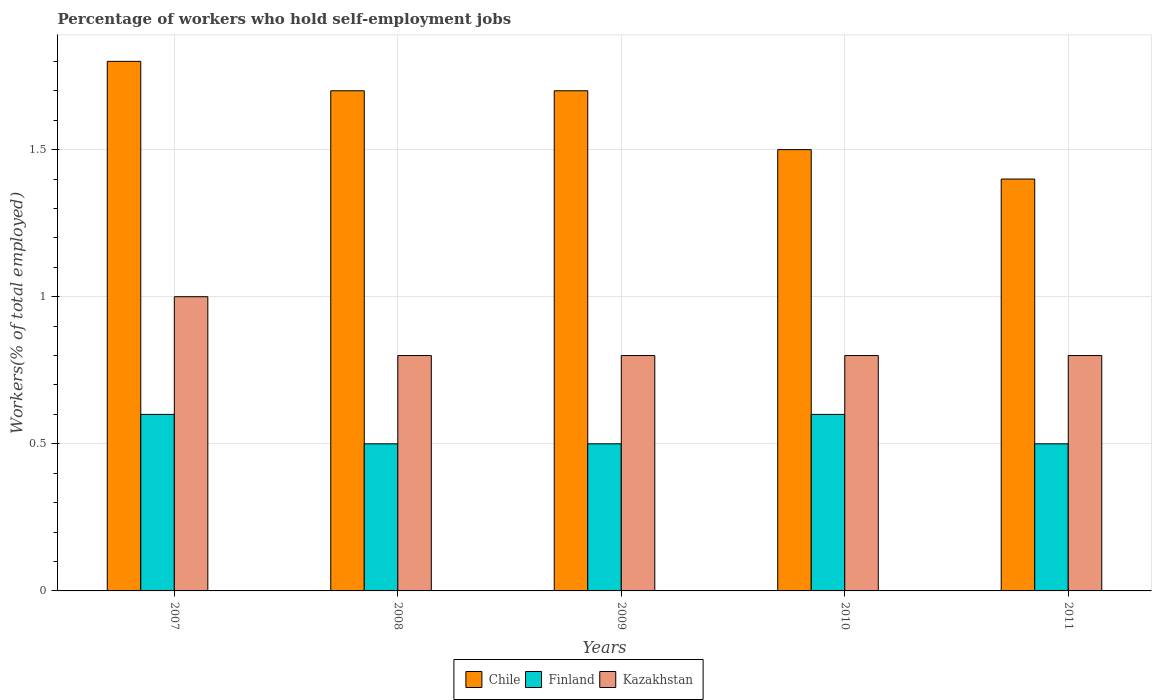How many different coloured bars are there?
Provide a short and direct response. 3. Are the number of bars per tick equal to the number of legend labels?
Your answer should be very brief. Yes. Are the number of bars on each tick of the X-axis equal?
Make the answer very short. Yes. In how many cases, is the number of bars for a given year not equal to the number of legend labels?
Offer a terse response. 0. What is the percentage of self-employed workers in Chile in 2011?
Ensure brevity in your answer.  1.4. Across all years, what is the maximum percentage of self-employed workers in Chile?
Provide a short and direct response. 1.8. Across all years, what is the minimum percentage of self-employed workers in Kazakhstan?
Offer a terse response. 0.8. In which year was the percentage of self-employed workers in Chile maximum?
Give a very brief answer. 2007. What is the total percentage of self-employed workers in Chile in the graph?
Keep it short and to the point. 8.1. What is the difference between the percentage of self-employed workers in Finland in 2007 and that in 2009?
Provide a short and direct response. 0.1. What is the difference between the percentage of self-employed workers in Finland in 2008 and the percentage of self-employed workers in Chile in 2009?
Offer a very short reply. -1.2. What is the average percentage of self-employed workers in Chile per year?
Give a very brief answer. 1.62. In the year 2007, what is the difference between the percentage of self-employed workers in Finland and percentage of self-employed workers in Chile?
Offer a very short reply. -1.2. What is the ratio of the percentage of self-employed workers in Chile in 2010 to that in 2011?
Keep it short and to the point. 1.07. Is the difference between the percentage of self-employed workers in Finland in 2008 and 2011 greater than the difference between the percentage of self-employed workers in Chile in 2008 and 2011?
Provide a short and direct response. No. What is the difference between the highest and the second highest percentage of self-employed workers in Kazakhstan?
Your answer should be compact. 0.2. What is the difference between the highest and the lowest percentage of self-employed workers in Chile?
Ensure brevity in your answer.  0.4. In how many years, is the percentage of self-employed workers in Chile greater than the average percentage of self-employed workers in Chile taken over all years?
Your answer should be very brief. 3. Are all the bars in the graph horizontal?
Make the answer very short. No. How many years are there in the graph?
Make the answer very short. 5. Where does the legend appear in the graph?
Keep it short and to the point. Bottom center. How many legend labels are there?
Make the answer very short. 3. How are the legend labels stacked?
Ensure brevity in your answer.  Horizontal. What is the title of the graph?
Your response must be concise. Percentage of workers who hold self-employment jobs. What is the label or title of the Y-axis?
Your response must be concise. Workers(% of total employed). What is the Workers(% of total employed) in Chile in 2007?
Provide a short and direct response. 1.8. What is the Workers(% of total employed) in Finland in 2007?
Your answer should be very brief. 0.6. What is the Workers(% of total employed) in Kazakhstan in 2007?
Your answer should be compact. 1. What is the Workers(% of total employed) in Chile in 2008?
Make the answer very short. 1.7. What is the Workers(% of total employed) of Kazakhstan in 2008?
Ensure brevity in your answer.  0.8. What is the Workers(% of total employed) of Chile in 2009?
Your answer should be very brief. 1.7. What is the Workers(% of total employed) of Finland in 2009?
Your answer should be very brief. 0.5. What is the Workers(% of total employed) in Kazakhstan in 2009?
Offer a terse response. 0.8. What is the Workers(% of total employed) in Chile in 2010?
Keep it short and to the point. 1.5. What is the Workers(% of total employed) in Finland in 2010?
Your answer should be very brief. 0.6. What is the Workers(% of total employed) in Kazakhstan in 2010?
Your answer should be very brief. 0.8. What is the Workers(% of total employed) of Chile in 2011?
Your answer should be very brief. 1.4. What is the Workers(% of total employed) of Finland in 2011?
Your answer should be very brief. 0.5. What is the Workers(% of total employed) in Kazakhstan in 2011?
Give a very brief answer. 0.8. Across all years, what is the maximum Workers(% of total employed) in Chile?
Provide a short and direct response. 1.8. Across all years, what is the maximum Workers(% of total employed) of Finland?
Ensure brevity in your answer.  0.6. Across all years, what is the maximum Workers(% of total employed) of Kazakhstan?
Ensure brevity in your answer.  1. Across all years, what is the minimum Workers(% of total employed) of Chile?
Your answer should be very brief. 1.4. Across all years, what is the minimum Workers(% of total employed) of Kazakhstan?
Keep it short and to the point. 0.8. What is the total Workers(% of total employed) of Kazakhstan in the graph?
Provide a succinct answer. 4.2. What is the difference between the Workers(% of total employed) in Finland in 2007 and that in 2008?
Ensure brevity in your answer.  0.1. What is the difference between the Workers(% of total employed) in Chile in 2007 and that in 2009?
Give a very brief answer. 0.1. What is the difference between the Workers(% of total employed) in Kazakhstan in 2007 and that in 2009?
Make the answer very short. 0.2. What is the difference between the Workers(% of total employed) in Chile in 2007 and that in 2010?
Keep it short and to the point. 0.3. What is the difference between the Workers(% of total employed) of Finland in 2007 and that in 2010?
Your answer should be very brief. 0. What is the difference between the Workers(% of total employed) in Chile in 2008 and that in 2009?
Give a very brief answer. 0. What is the difference between the Workers(% of total employed) of Chile in 2008 and that in 2010?
Your answer should be compact. 0.2. What is the difference between the Workers(% of total employed) in Finland in 2008 and that in 2010?
Provide a succinct answer. -0.1. What is the difference between the Workers(% of total employed) of Finland in 2008 and that in 2011?
Provide a succinct answer. 0. What is the difference between the Workers(% of total employed) of Chile in 2009 and that in 2010?
Ensure brevity in your answer.  0.2. What is the difference between the Workers(% of total employed) in Finland in 2009 and that in 2010?
Give a very brief answer. -0.1. What is the difference between the Workers(% of total employed) in Chile in 2009 and that in 2011?
Offer a terse response. 0.3. What is the difference between the Workers(% of total employed) of Chile in 2010 and that in 2011?
Offer a very short reply. 0.1. What is the difference between the Workers(% of total employed) of Finland in 2010 and that in 2011?
Offer a terse response. 0.1. What is the difference between the Workers(% of total employed) in Kazakhstan in 2010 and that in 2011?
Offer a very short reply. 0. What is the difference between the Workers(% of total employed) of Chile in 2007 and the Workers(% of total employed) of Finland in 2008?
Ensure brevity in your answer.  1.3. What is the difference between the Workers(% of total employed) of Chile in 2007 and the Workers(% of total employed) of Kazakhstan in 2009?
Provide a succinct answer. 1. What is the difference between the Workers(% of total employed) of Chile in 2007 and the Workers(% of total employed) of Finland in 2010?
Offer a very short reply. 1.2. What is the difference between the Workers(% of total employed) in Chile in 2007 and the Workers(% of total employed) in Kazakhstan in 2010?
Your response must be concise. 1. What is the difference between the Workers(% of total employed) in Finland in 2007 and the Workers(% of total employed) in Kazakhstan in 2010?
Your response must be concise. -0.2. What is the difference between the Workers(% of total employed) in Finland in 2007 and the Workers(% of total employed) in Kazakhstan in 2011?
Your response must be concise. -0.2. What is the difference between the Workers(% of total employed) of Chile in 2008 and the Workers(% of total employed) of Kazakhstan in 2009?
Ensure brevity in your answer.  0.9. What is the difference between the Workers(% of total employed) in Finland in 2008 and the Workers(% of total employed) in Kazakhstan in 2009?
Offer a very short reply. -0.3. What is the difference between the Workers(% of total employed) of Chile in 2008 and the Workers(% of total employed) of Finland in 2011?
Your answer should be very brief. 1.2. What is the difference between the Workers(% of total employed) of Chile in 2008 and the Workers(% of total employed) of Kazakhstan in 2011?
Keep it short and to the point. 0.9. What is the difference between the Workers(% of total employed) of Finland in 2008 and the Workers(% of total employed) of Kazakhstan in 2011?
Ensure brevity in your answer.  -0.3. What is the difference between the Workers(% of total employed) of Chile in 2009 and the Workers(% of total employed) of Finland in 2010?
Offer a very short reply. 1.1. What is the difference between the Workers(% of total employed) in Chile in 2009 and the Workers(% of total employed) in Kazakhstan in 2010?
Your response must be concise. 0.9. What is the difference between the Workers(% of total employed) in Finland in 2009 and the Workers(% of total employed) in Kazakhstan in 2010?
Keep it short and to the point. -0.3. What is the difference between the Workers(% of total employed) in Chile in 2009 and the Workers(% of total employed) in Finland in 2011?
Make the answer very short. 1.2. What is the difference between the Workers(% of total employed) of Chile in 2009 and the Workers(% of total employed) of Kazakhstan in 2011?
Ensure brevity in your answer.  0.9. What is the difference between the Workers(% of total employed) in Chile in 2010 and the Workers(% of total employed) in Finland in 2011?
Your answer should be very brief. 1. What is the difference between the Workers(% of total employed) of Finland in 2010 and the Workers(% of total employed) of Kazakhstan in 2011?
Provide a short and direct response. -0.2. What is the average Workers(% of total employed) in Chile per year?
Offer a terse response. 1.62. What is the average Workers(% of total employed) in Finland per year?
Offer a terse response. 0.54. What is the average Workers(% of total employed) in Kazakhstan per year?
Make the answer very short. 0.84. In the year 2008, what is the difference between the Workers(% of total employed) in Chile and Workers(% of total employed) in Finland?
Provide a short and direct response. 1.2. In the year 2008, what is the difference between the Workers(% of total employed) of Chile and Workers(% of total employed) of Kazakhstan?
Provide a succinct answer. 0.9. In the year 2008, what is the difference between the Workers(% of total employed) of Finland and Workers(% of total employed) of Kazakhstan?
Give a very brief answer. -0.3. In the year 2009, what is the difference between the Workers(% of total employed) of Chile and Workers(% of total employed) of Finland?
Provide a short and direct response. 1.2. In the year 2009, what is the difference between the Workers(% of total employed) of Chile and Workers(% of total employed) of Kazakhstan?
Give a very brief answer. 0.9. In the year 2010, what is the difference between the Workers(% of total employed) in Chile and Workers(% of total employed) in Finland?
Provide a short and direct response. 0.9. In the year 2011, what is the difference between the Workers(% of total employed) of Chile and Workers(% of total employed) of Finland?
Give a very brief answer. 0.9. In the year 2011, what is the difference between the Workers(% of total employed) of Finland and Workers(% of total employed) of Kazakhstan?
Provide a succinct answer. -0.3. What is the ratio of the Workers(% of total employed) in Chile in 2007 to that in 2008?
Provide a short and direct response. 1.06. What is the ratio of the Workers(% of total employed) of Finland in 2007 to that in 2008?
Make the answer very short. 1.2. What is the ratio of the Workers(% of total employed) of Chile in 2007 to that in 2009?
Provide a succinct answer. 1.06. What is the ratio of the Workers(% of total employed) in Finland in 2007 to that in 2011?
Your answer should be compact. 1.2. What is the ratio of the Workers(% of total employed) in Kazakhstan in 2007 to that in 2011?
Ensure brevity in your answer.  1.25. What is the ratio of the Workers(% of total employed) in Finland in 2008 to that in 2009?
Offer a very short reply. 1. What is the ratio of the Workers(% of total employed) of Chile in 2008 to that in 2010?
Make the answer very short. 1.13. What is the ratio of the Workers(% of total employed) in Finland in 2008 to that in 2010?
Offer a terse response. 0.83. What is the ratio of the Workers(% of total employed) in Chile in 2008 to that in 2011?
Make the answer very short. 1.21. What is the ratio of the Workers(% of total employed) in Finland in 2008 to that in 2011?
Your response must be concise. 1. What is the ratio of the Workers(% of total employed) of Kazakhstan in 2008 to that in 2011?
Provide a succinct answer. 1. What is the ratio of the Workers(% of total employed) in Chile in 2009 to that in 2010?
Give a very brief answer. 1.13. What is the ratio of the Workers(% of total employed) of Kazakhstan in 2009 to that in 2010?
Keep it short and to the point. 1. What is the ratio of the Workers(% of total employed) in Chile in 2009 to that in 2011?
Provide a short and direct response. 1.21. What is the ratio of the Workers(% of total employed) in Finland in 2009 to that in 2011?
Your response must be concise. 1. What is the ratio of the Workers(% of total employed) in Kazakhstan in 2009 to that in 2011?
Offer a terse response. 1. What is the ratio of the Workers(% of total employed) of Chile in 2010 to that in 2011?
Your response must be concise. 1.07. What is the difference between the highest and the second highest Workers(% of total employed) in Chile?
Your response must be concise. 0.1. What is the difference between the highest and the second highest Workers(% of total employed) of Finland?
Offer a terse response. 0. What is the difference between the highest and the lowest Workers(% of total employed) in Chile?
Provide a short and direct response. 0.4. What is the difference between the highest and the lowest Workers(% of total employed) of Finland?
Give a very brief answer. 0.1. What is the difference between the highest and the lowest Workers(% of total employed) in Kazakhstan?
Provide a short and direct response. 0.2. 